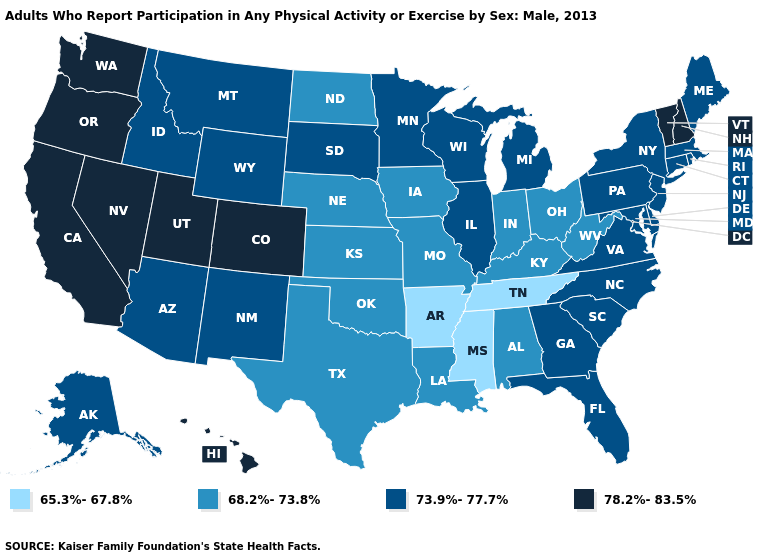Does Washington have the highest value in the USA?
Concise answer only. Yes. Which states have the highest value in the USA?
Write a very short answer. California, Colorado, Hawaii, Nevada, New Hampshire, Oregon, Utah, Vermont, Washington. Name the states that have a value in the range 73.9%-77.7%?
Give a very brief answer. Alaska, Arizona, Connecticut, Delaware, Florida, Georgia, Idaho, Illinois, Maine, Maryland, Massachusetts, Michigan, Minnesota, Montana, New Jersey, New Mexico, New York, North Carolina, Pennsylvania, Rhode Island, South Carolina, South Dakota, Virginia, Wisconsin, Wyoming. Does the first symbol in the legend represent the smallest category?
Give a very brief answer. Yes. What is the value of New York?
Write a very short answer. 73.9%-77.7%. Name the states that have a value in the range 73.9%-77.7%?
Write a very short answer. Alaska, Arizona, Connecticut, Delaware, Florida, Georgia, Idaho, Illinois, Maine, Maryland, Massachusetts, Michigan, Minnesota, Montana, New Jersey, New Mexico, New York, North Carolina, Pennsylvania, Rhode Island, South Carolina, South Dakota, Virginia, Wisconsin, Wyoming. What is the value of Georgia?
Keep it brief. 73.9%-77.7%. Is the legend a continuous bar?
Be succinct. No. Which states have the lowest value in the MidWest?
Keep it brief. Indiana, Iowa, Kansas, Missouri, Nebraska, North Dakota, Ohio. Does Alabama have a higher value than Mississippi?
Write a very short answer. Yes. How many symbols are there in the legend?
Give a very brief answer. 4. Name the states that have a value in the range 73.9%-77.7%?
Answer briefly. Alaska, Arizona, Connecticut, Delaware, Florida, Georgia, Idaho, Illinois, Maine, Maryland, Massachusetts, Michigan, Minnesota, Montana, New Jersey, New Mexico, New York, North Carolina, Pennsylvania, Rhode Island, South Carolina, South Dakota, Virginia, Wisconsin, Wyoming. What is the value of California?
Concise answer only. 78.2%-83.5%. Name the states that have a value in the range 78.2%-83.5%?
Answer briefly. California, Colorado, Hawaii, Nevada, New Hampshire, Oregon, Utah, Vermont, Washington. What is the value of Illinois?
Give a very brief answer. 73.9%-77.7%. 